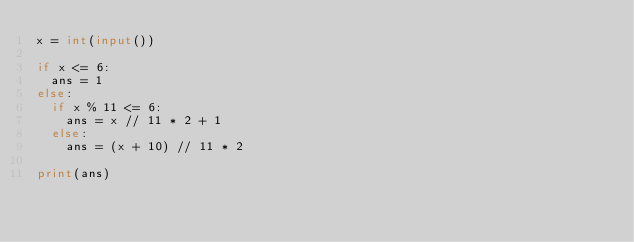Convert code to text. <code><loc_0><loc_0><loc_500><loc_500><_Python_>x = int(input())

if x <= 6:
  ans = 1
else:
  if x % 11 <= 6:
    ans = x // 11 * 2 + 1
  else:
    ans = (x + 10) // 11 * 2

print(ans)</code> 